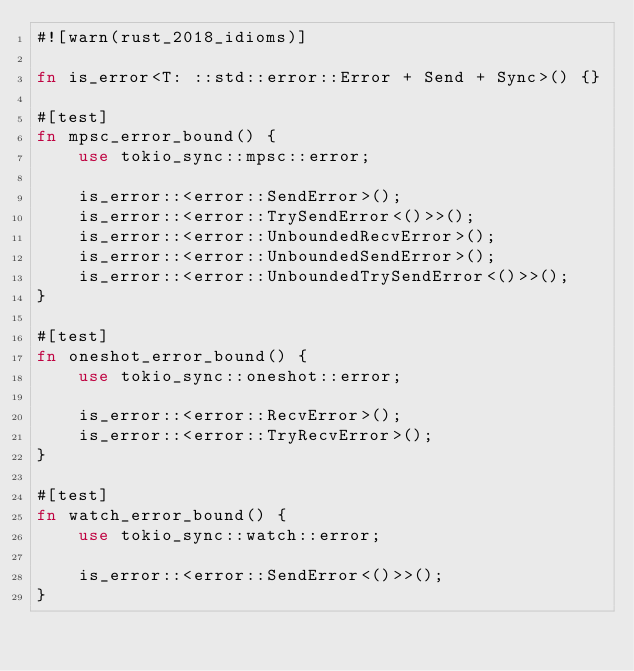Convert code to text. <code><loc_0><loc_0><loc_500><loc_500><_Rust_>#![warn(rust_2018_idioms)]

fn is_error<T: ::std::error::Error + Send + Sync>() {}

#[test]
fn mpsc_error_bound() {
    use tokio_sync::mpsc::error;

    is_error::<error::SendError>();
    is_error::<error::TrySendError<()>>();
    is_error::<error::UnboundedRecvError>();
    is_error::<error::UnboundedSendError>();
    is_error::<error::UnboundedTrySendError<()>>();
}

#[test]
fn oneshot_error_bound() {
    use tokio_sync::oneshot::error;

    is_error::<error::RecvError>();
    is_error::<error::TryRecvError>();
}

#[test]
fn watch_error_bound() {
    use tokio_sync::watch::error;

    is_error::<error::SendError<()>>();
}
</code> 